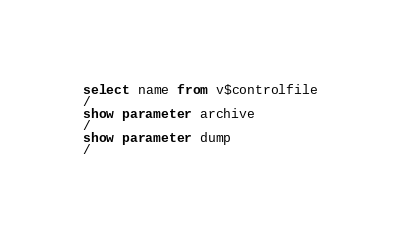Convert code to text. <code><loc_0><loc_0><loc_500><loc_500><_SQL_>select name from v$controlfile
/
show parameter archive
/
show parameter dump
/
</code> 